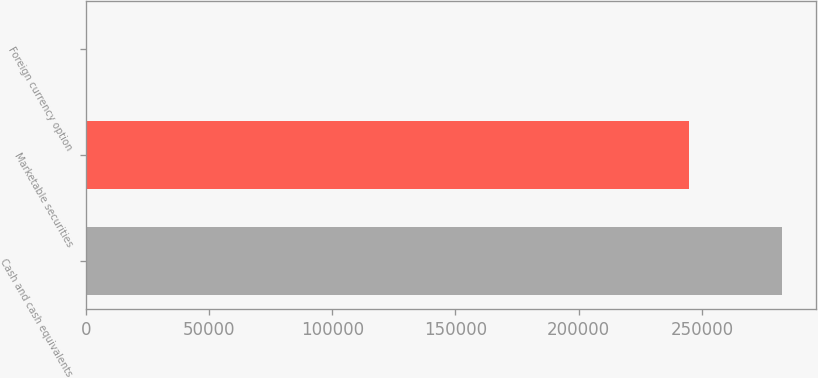Convert chart. <chart><loc_0><loc_0><loc_500><loc_500><bar_chart><fcel>Cash and cash equivalents<fcel>Marketable securities<fcel>Foreign currency option<nl><fcel>282249<fcel>244729<fcel>181<nl></chart> 